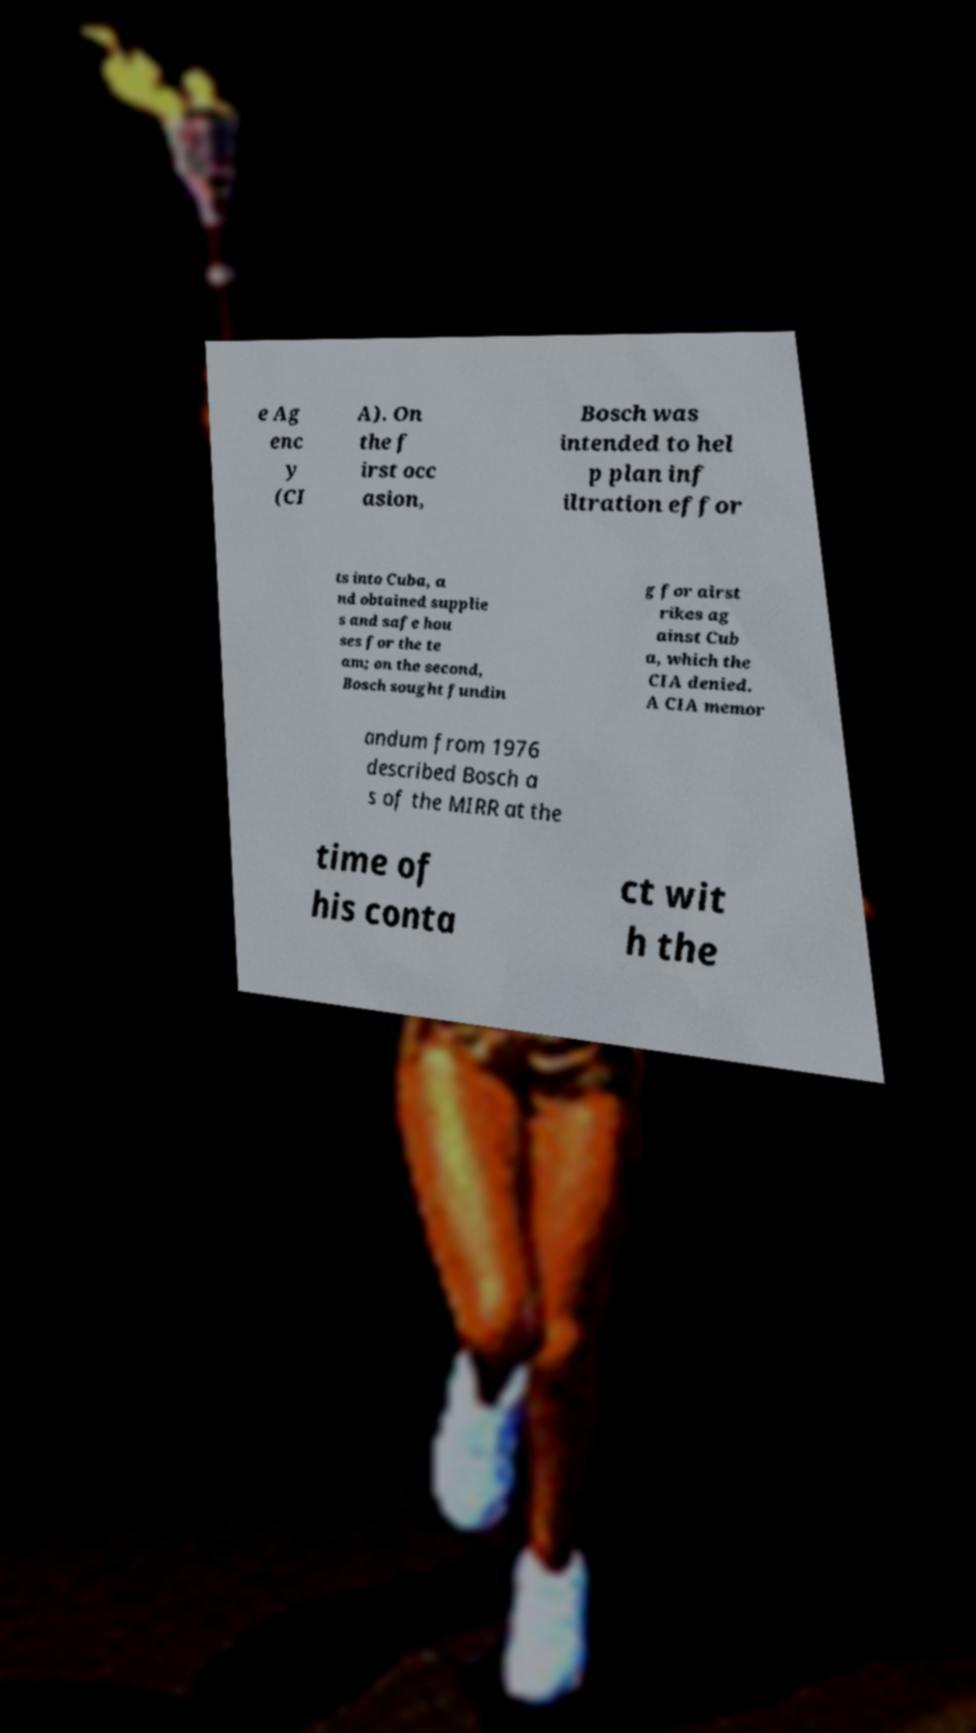Can you read and provide the text displayed in the image?This photo seems to have some interesting text. Can you extract and type it out for me? e Ag enc y (CI A). On the f irst occ asion, Bosch was intended to hel p plan inf iltration effor ts into Cuba, a nd obtained supplie s and safe hou ses for the te am; on the second, Bosch sought fundin g for airst rikes ag ainst Cub a, which the CIA denied. A CIA memor andum from 1976 described Bosch a s of the MIRR at the time of his conta ct wit h the 